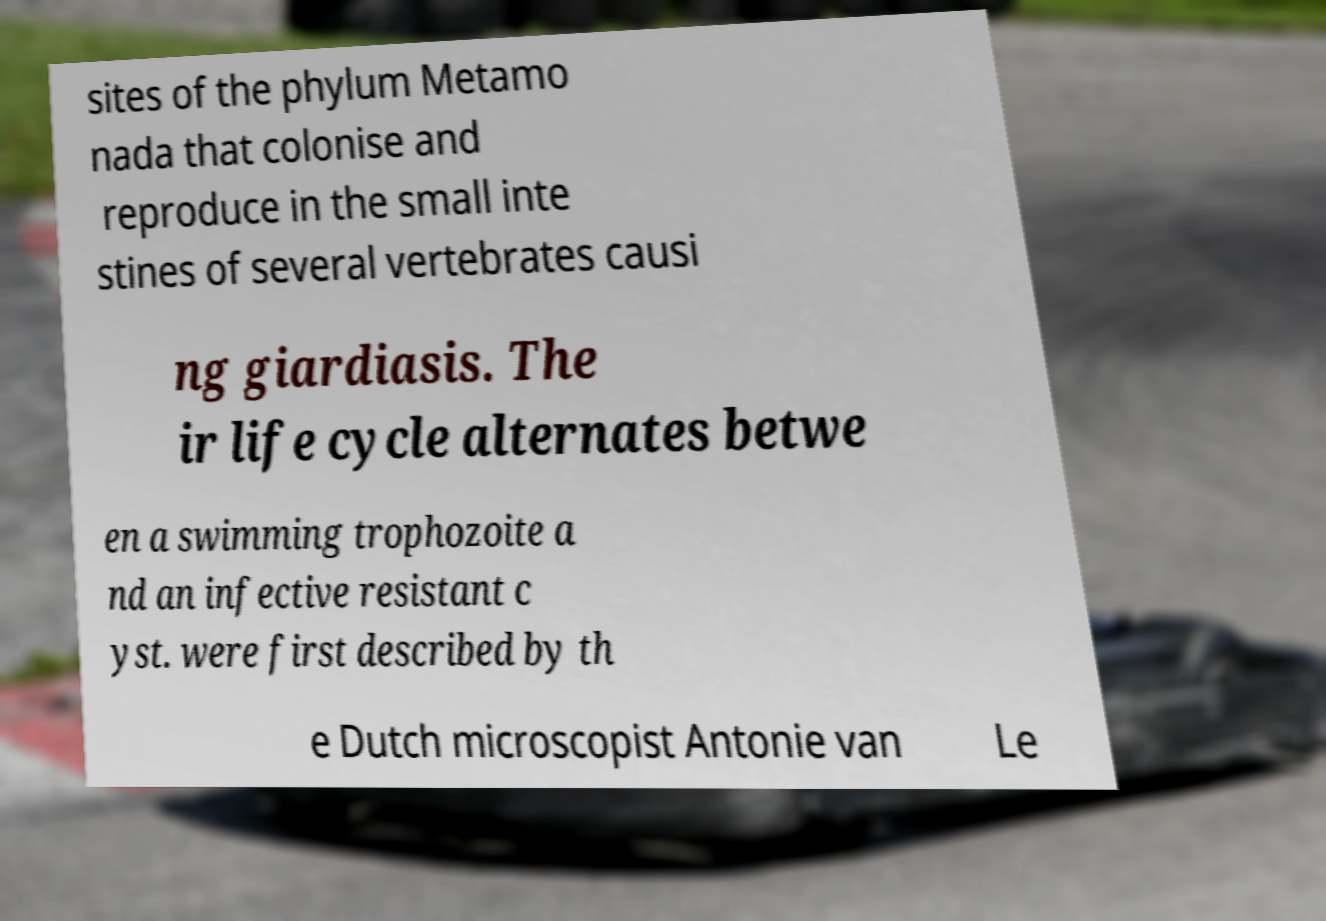Can you accurately transcribe the text from the provided image for me? sites of the phylum Metamo nada that colonise and reproduce in the small inte stines of several vertebrates causi ng giardiasis. The ir life cycle alternates betwe en a swimming trophozoite a nd an infective resistant c yst. were first described by th e Dutch microscopist Antonie van Le 